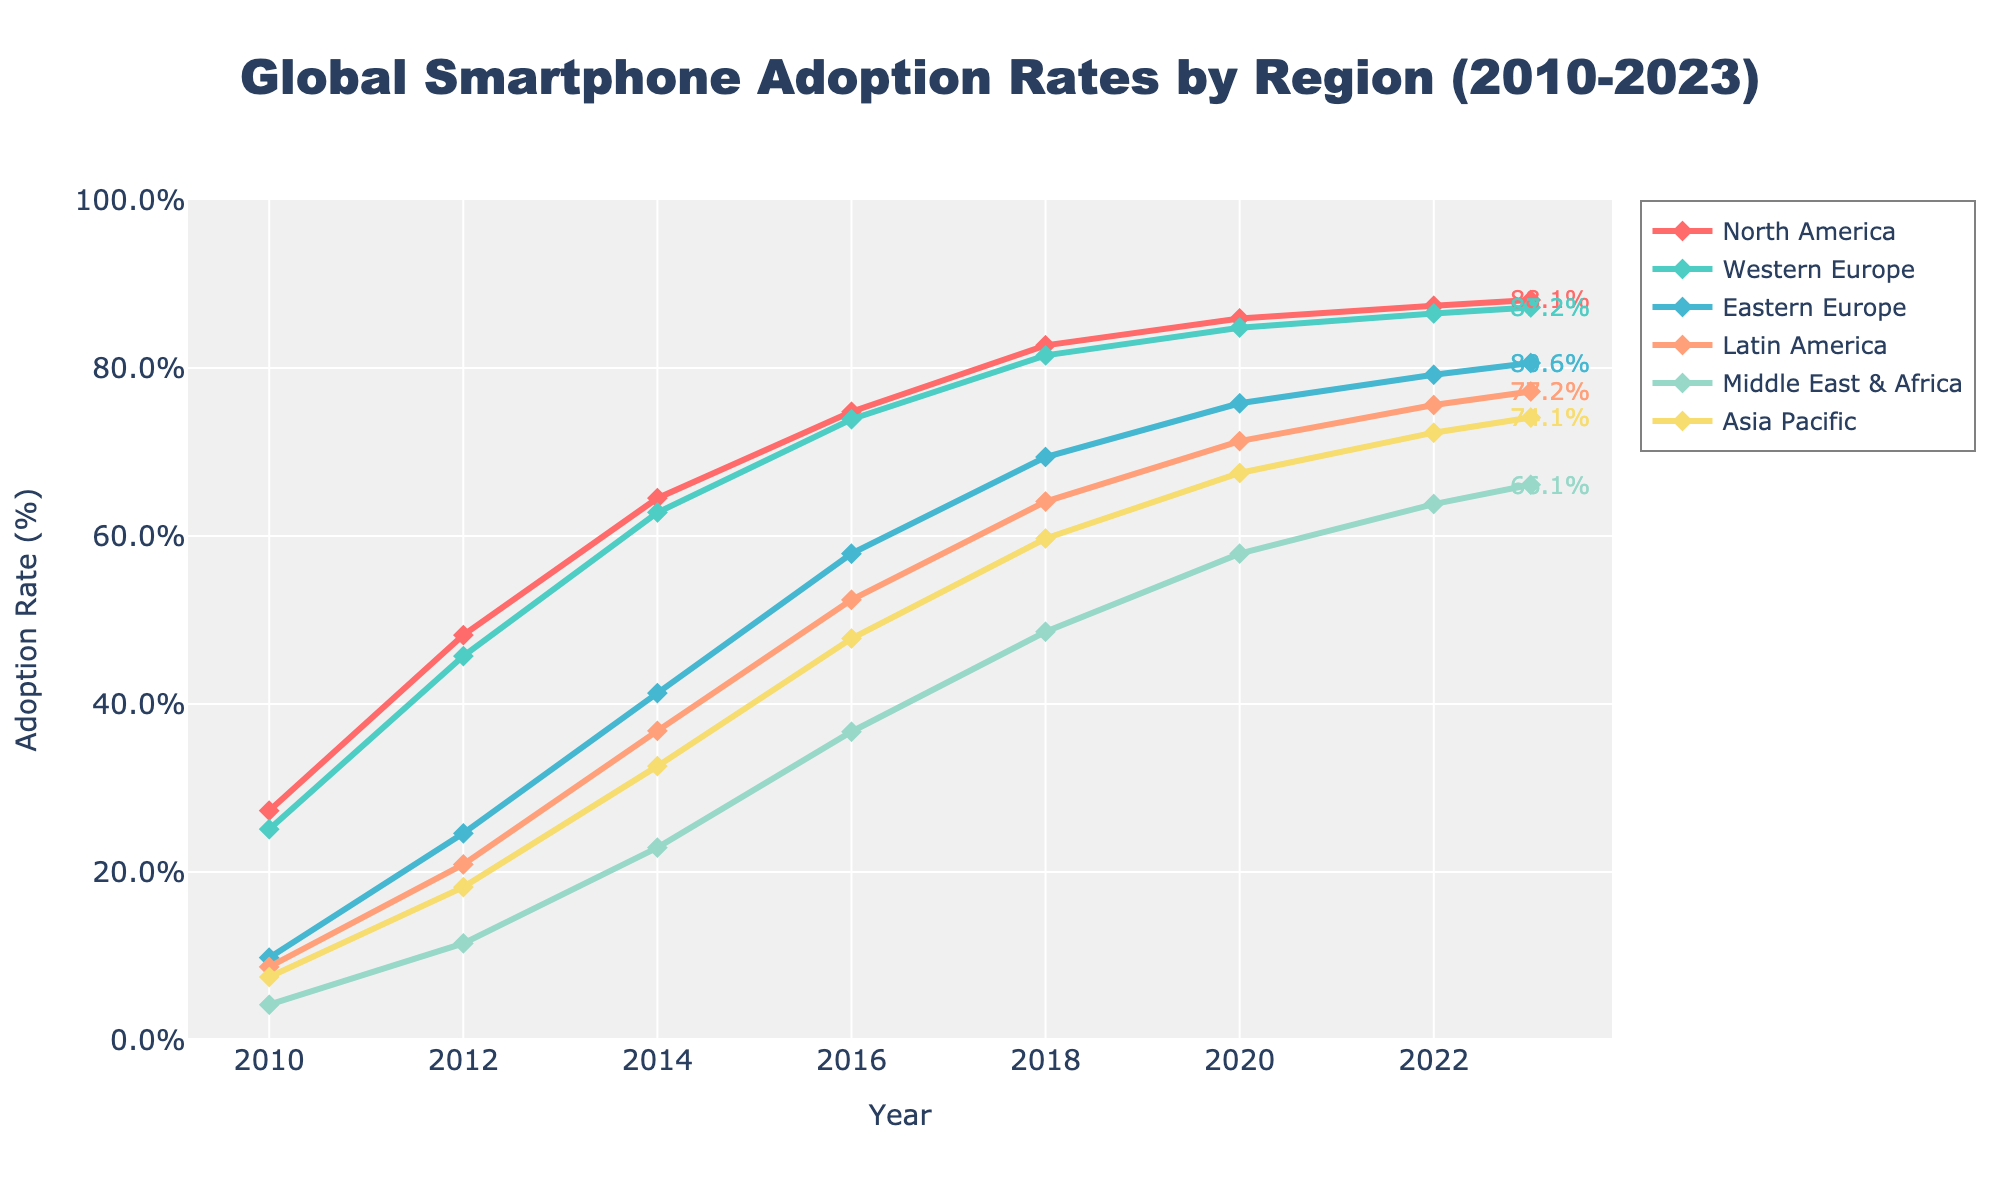Which region had the highest smartphone adoption rate in 2023? By looking at the endpoints of the chart, where each line ends at the year 2023, we can see that North America has the highest smartphone adoption rate.
Answer: North America Which region showed the most significant increase in adoption rate from 2010 to 2023? To find this, we need to look at the beginning and end values for each region and find the region with the highest increase. North America went from 27.3% to 88.1%, Western Europe from 25.1% to 87.2%, Eastern Europe from 9.8% to 80.6%, Latin America from 8.7% to 77.2%, Middle East & Africa from 4.2% to 66.1%, and Asia Pacific from 7.5% to 74.1%. The highest increase is for Eastern Europe, with an increase of 70.8%.
Answer: Eastern Europe In 2016, which region had a higher adoption rate: Asia Pacific or Latin America? By comparing the data points for the year 2016 for both regions, we see that Asia Pacific had an adoption rate of 47.8% and Latin America had 52.4%. Latin America is higher.
Answer: Latin America How much did the smartphone adoption rate in the Middle East & Africa increase from 2010 to 2012? We need to take the difference of the values for the Middle East & Africa between 2012 and 2010. The values are 11.5% (2012) and 4.2% (2010), so the increase is 11.5% - 4.2% = 7.3%.
Answer: 7.3% Which region had the lowest adoption rate in 2018? By looking at the data points for the year 2018 across all regions, we find: North America 82.7%, Western Europe 81.5%, Eastern Europe 69.4%, Latin America 64.1%, Middle East & Africa 48.6%, and Asia Pacific 59.7%. The lowest is Middle East & Africa.
Answer: Middle East & Africa What is the average smartphone adoption rate across all regions in 2014? Sum the adoption rates for 2014 across all regions and divide by the number of regions: (64.5 + 62.8 + 41.3 + 36.8 + 22.9 + 32.6) / 6 = 43.482%.
Answer: 43.5% How does the smartphone adoption rate in Western Europe in 2020 compare to that in North America in 2010? Western Europe's 2020 rate is 84.8%, and North America's 2010 rate is 27.3%. Comparing these, 84.8% > 27.3%.
Answer: Higher Among the regions, which one reached an adoption rate of at least 80% by 2020? We identify the regions with 2020 rates of at least 80% by checking if they meet or exceed 80%. North America had 85.9%, Western Europe had 84.8%, no other regions meet this threshold by 2020.
Answer: North America, Western Europe Compare the trends for Latin America and Asia Pacific from 2012 to 2018. Which region had a steeper increase in adoption rate? First calculate the increase for both regions: Latin America from 20.9% to 64.1%, yielding an increase of 64.1% - 20.9% = 43.2%. Asia Pacific from 18.2% to 59.7%, yielding an increase of 59.7% - 18.2% = 41.5%. Latin America had a steeper increase.
Answer: Latin America What was the difference in smartphone adoption rates between Eastern Europe and Western Europe in 2016? The adoption rates for 2016 are 57.9% for Eastern Europe and 73.9% for Western Europe. The difference is 73.9% - 57.9% = 16%.
Answer: 16% 